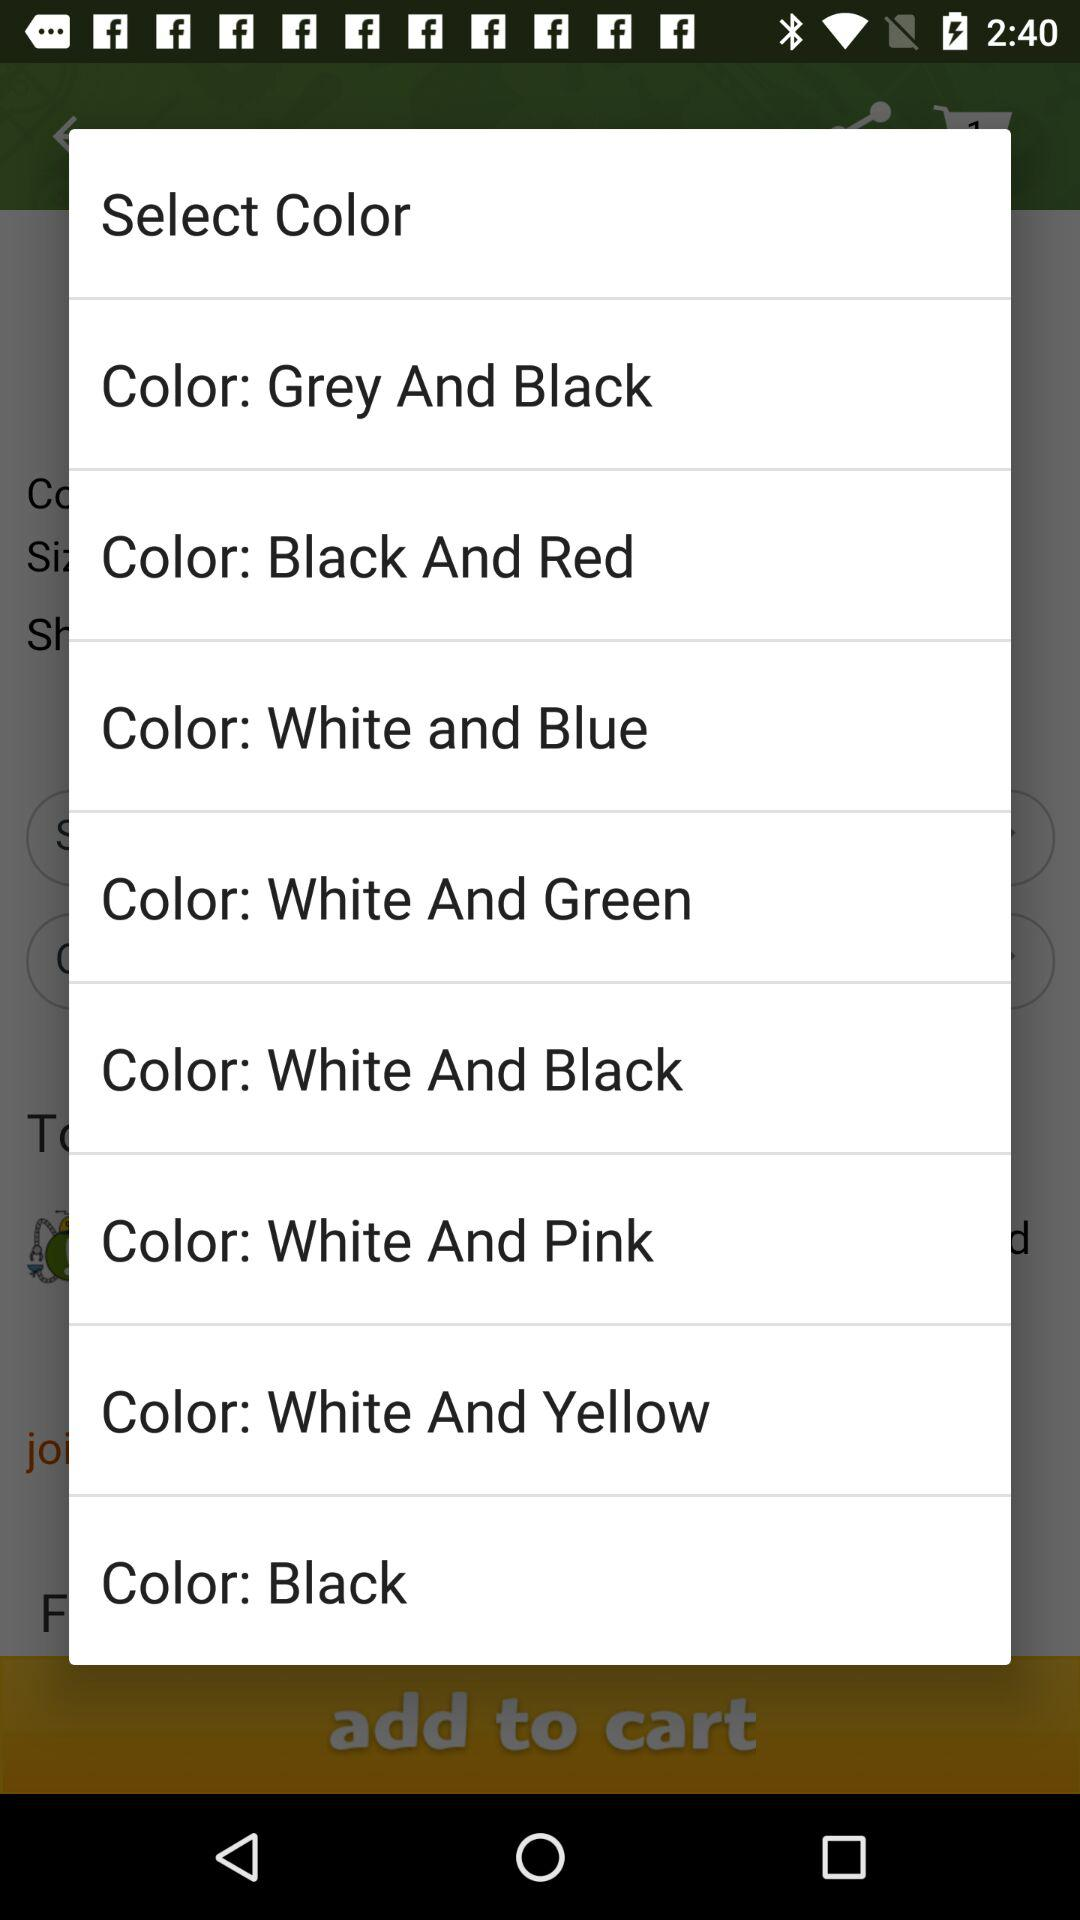How many color options are there?
Answer the question using a single word or phrase. 8 